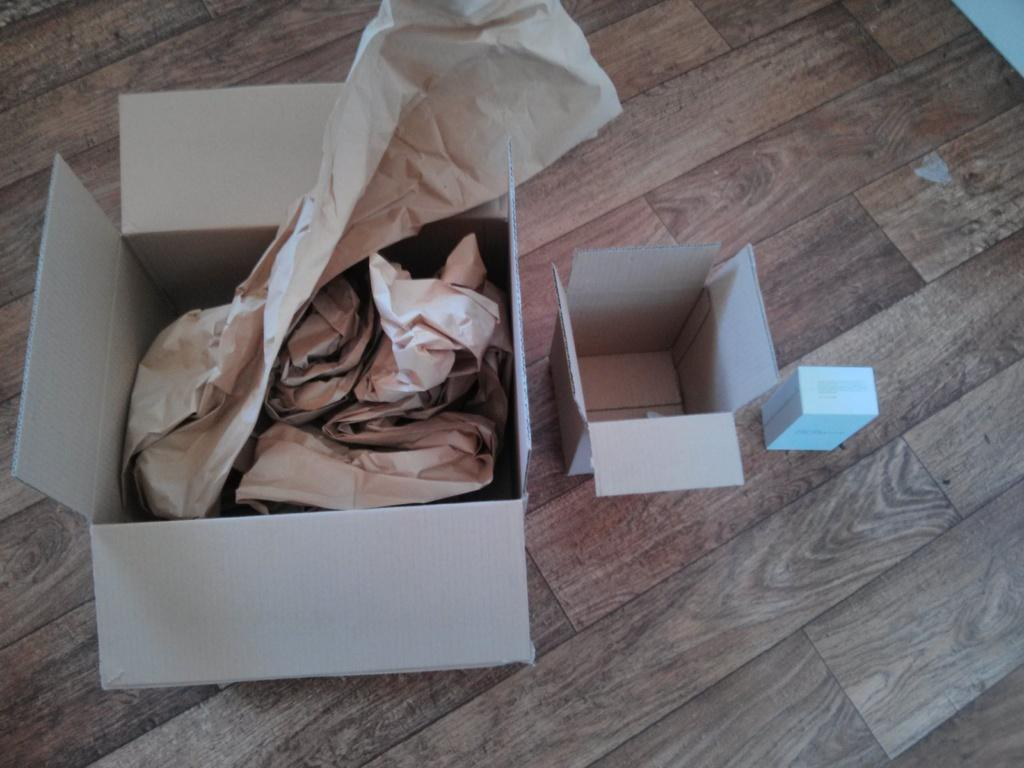How many boxes are visible in the image? There are three boxes in the image. What is the material of the surface on which the boxes are placed? The surface is made of wood. Can you describe the contents of any of the boxes? There is a paper in one of the boxes. Is there a badge attached to any of the boxes in the image? There is no mention of a badge in the image, so it cannot be determined if one is present. 